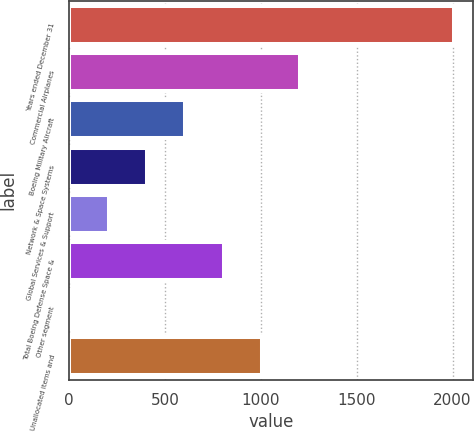<chart> <loc_0><loc_0><loc_500><loc_500><bar_chart><fcel>Years ended December 31<fcel>Commercial Airplanes<fcel>Boeing Military Aircraft<fcel>Network & Space Systems<fcel>Global Services & Support<fcel>Total Boeing Defense Space &<fcel>Other segment<fcel>Unallocated items and<nl><fcel>2007<fcel>1206.2<fcel>605.6<fcel>405.4<fcel>205.2<fcel>805.8<fcel>5<fcel>1006<nl></chart> 